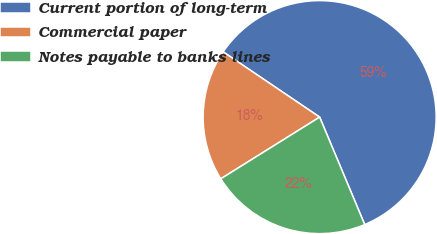Convert chart. <chart><loc_0><loc_0><loc_500><loc_500><pie_chart><fcel>Current portion of long-term<fcel>Commercial paper<fcel>Notes payable to banks lines<nl><fcel>59.22%<fcel>18.35%<fcel>22.44%<nl></chart> 